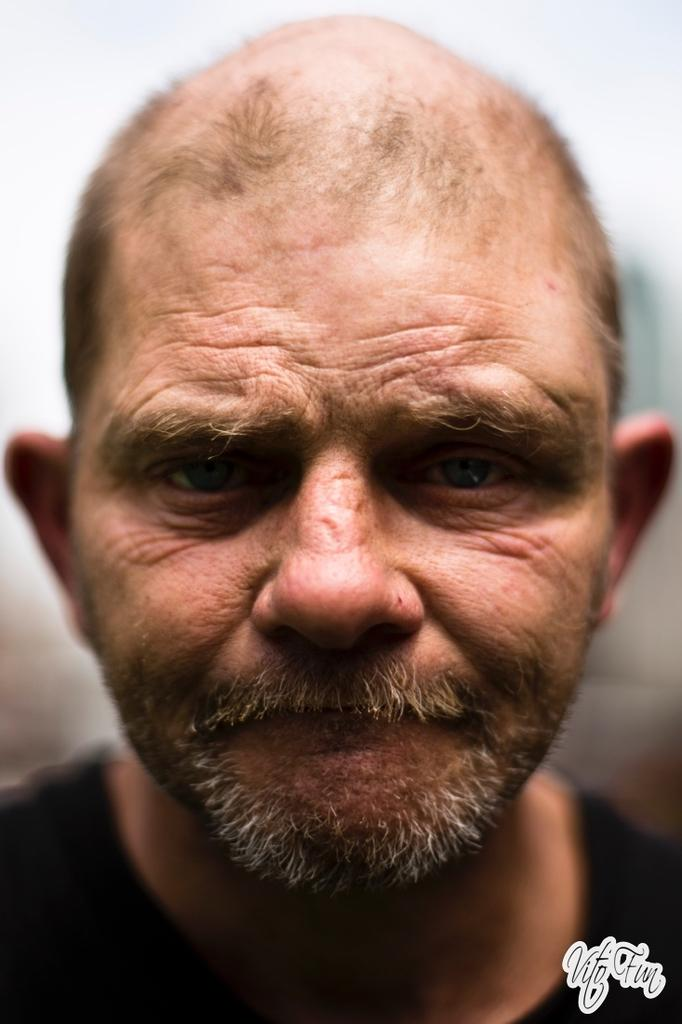What is the main subject of the image? There is a person in the image. Can you describe any additional features or elements in the image? There is a watermark in the bottom right corner of the image. How many cattle can be seen grazing in the background of the image? There are no cattle present in the image. What type of spot is visible on the person's clothing in the image? There is no spot visible on the person's clothing in the image. 